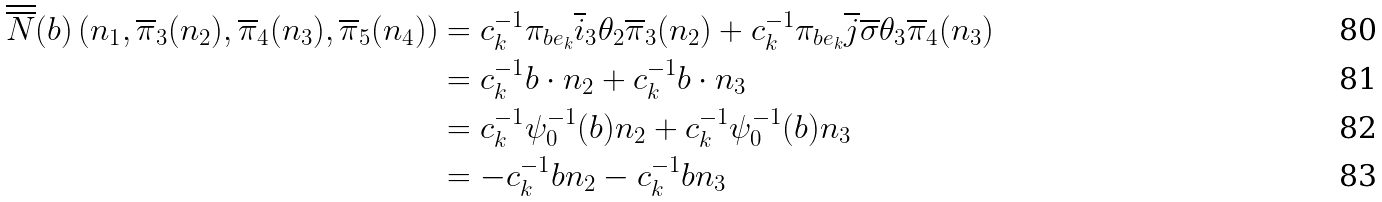Convert formula to latex. <formula><loc_0><loc_0><loc_500><loc_500>\overline { \overline { N } } ( b ) \left ( n _ { 1 } , \overline { \pi } _ { 3 } ( n _ { 2 } ) , \overline { \pi } _ { 4 } ( n _ { 3 } ) , \overline { \pi } _ { 5 } ( n _ { 4 } ) \right ) & = c _ { k } ^ { - 1 } \pi _ { b e _ { k } } \overline { i } _ { 3 } \theta _ { 2 } \overline { \pi } _ { 3 } ( n _ { 2 } ) + c _ { k } ^ { - 1 } \pi _ { b e _ { k } } \overline { j } \overline { \sigma } \theta _ { 3 } \overline { \pi } _ { 4 } ( n _ { 3 } ) \\ & = c _ { k } ^ { - 1 } b \cdot n _ { 2 } + c _ { k } ^ { - 1 } b \cdot n _ { 3 } \\ & = c _ { k } ^ { - 1 } \psi _ { 0 } ^ { - 1 } ( b ) n _ { 2 } + c _ { k } ^ { - 1 } \psi _ { 0 } ^ { - 1 } ( b ) n _ { 3 } \\ & = - c _ { k } ^ { - 1 } b n _ { 2 } - c _ { k } ^ { - 1 } b n _ { 3 }</formula> 